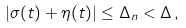Convert formula to latex. <formula><loc_0><loc_0><loc_500><loc_500>| \sigma ( t ) + \eta ( t ) | \leq \Delta _ { n } < \Delta \, ,</formula> 